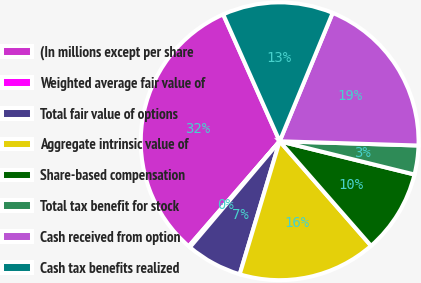Convert chart. <chart><loc_0><loc_0><loc_500><loc_500><pie_chart><fcel>(In millions except per share<fcel>Weighted average fair value of<fcel>Total fair value of options<fcel>Aggregate intrinsic value of<fcel>Share-based compensation<fcel>Total tax benefit for stock<fcel>Cash received from option<fcel>Cash tax benefits realized<nl><fcel>31.98%<fcel>0.18%<fcel>6.54%<fcel>16.08%<fcel>9.72%<fcel>3.36%<fcel>19.26%<fcel>12.9%<nl></chart> 